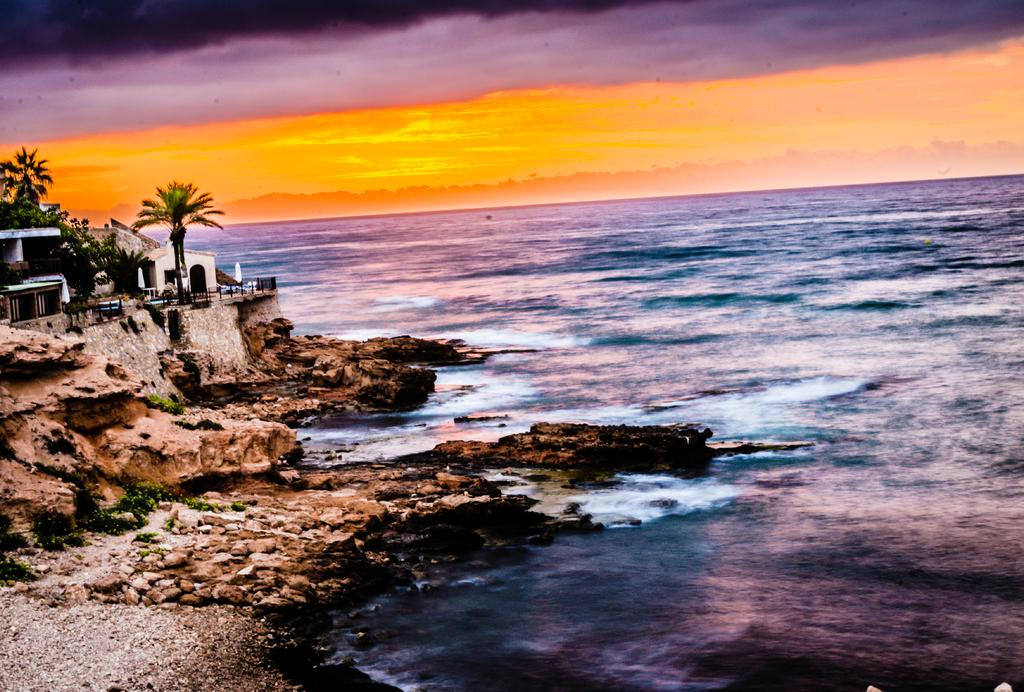What editing has been done to the image? The image has been edited, but the specific editing details are not mentioned in the facts. What type of natural feature can be seen on the right side of the image? There is an ocean on the right side of the image. What type of objects can be seen on the left side of the image? There are rocks, buildings, and trees on the left side of the image. What is visible at the top of the image? The sky is visible at the top of the image. What is the opinion of the car in the image? There is no car present in the image, so it is not possible to determine its opinion. 